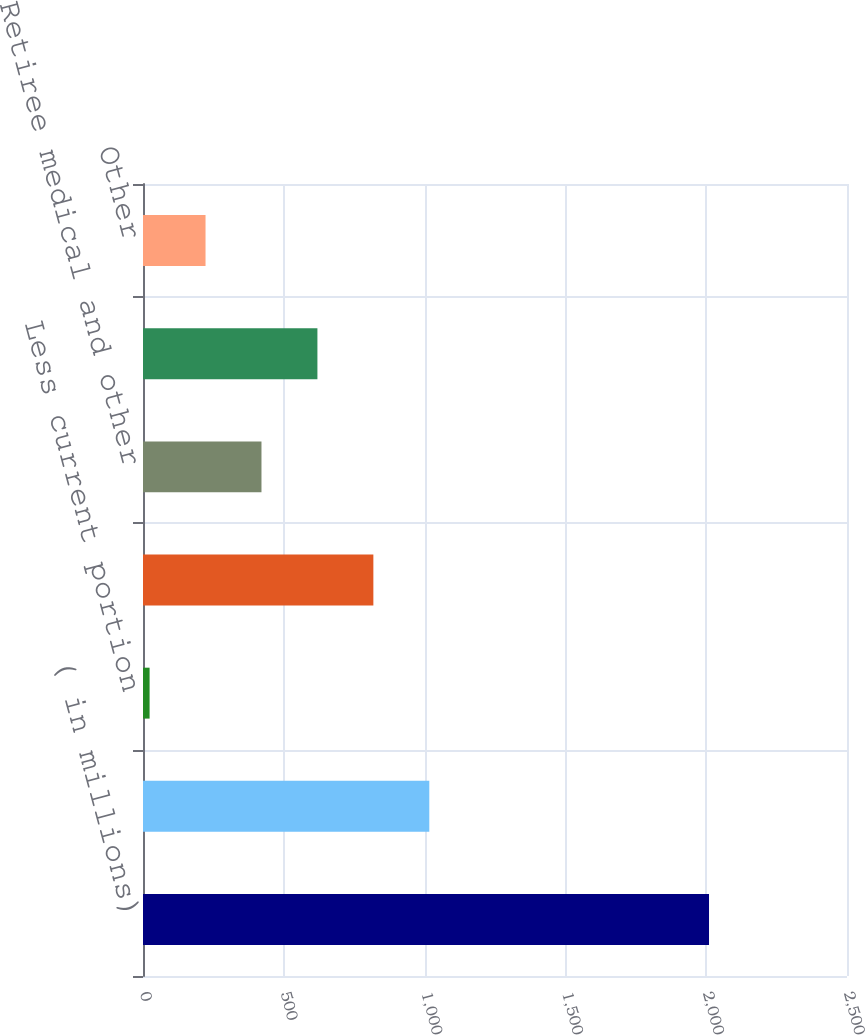<chart> <loc_0><loc_0><loc_500><loc_500><bar_chart><fcel>( in millions)<fcel>Total defined benefit pension<fcel>Less current portion<fcel>Long-term defined benefit<fcel>Retiree medical and other<fcel>Deferred compensation plans<fcel>Other<nl><fcel>2010<fcel>1016.7<fcel>23.4<fcel>818.04<fcel>420.72<fcel>619.38<fcel>222.06<nl></chart> 